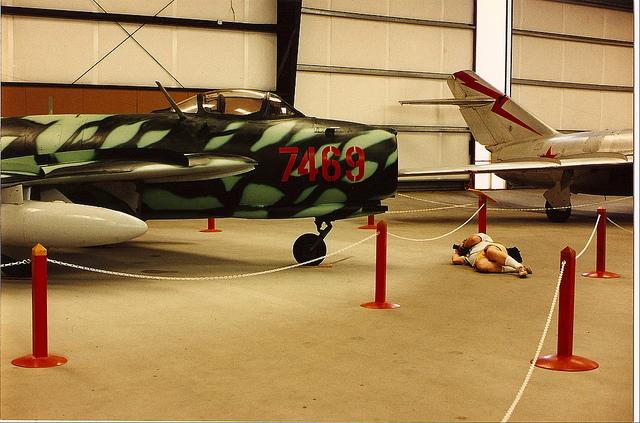What is the person on the floor holding?
Answer briefly. Camera. What keeps people from touching the planes?
Be succinct. Ropes. What number is in red?
Short answer required. 7469. 